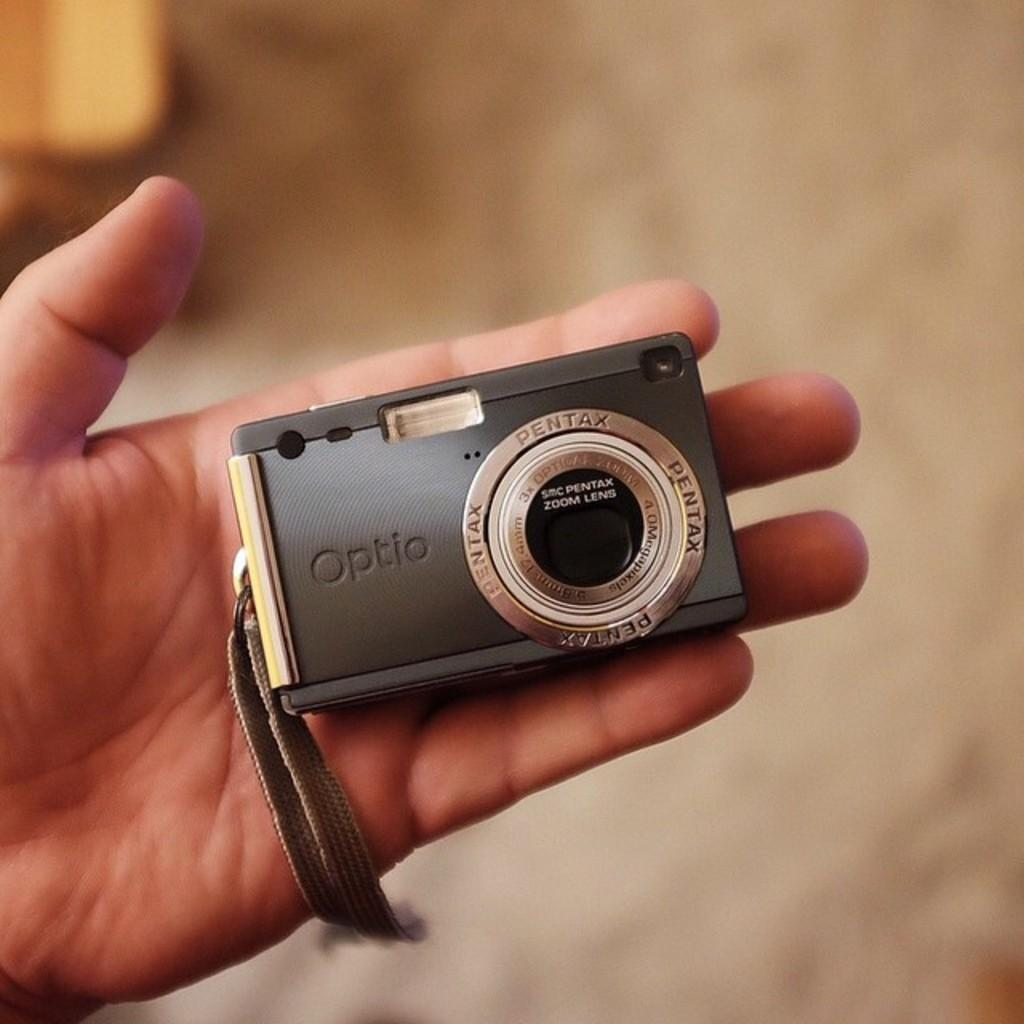What object is being held by a person in the image? There is a camera in the image, and it is being held by a person. What can be inferred about the person's activity based on the presence of the camera? The person is likely taking a photograph or recording a video. What is the condition of the background in the image? The background of the image is blurred. What type of ring can be seen on the person's finger in the image? There is no ring visible on the person's finger in the image. What channel is the person watching on the camera in the image? The image does not depict a television or any channel being watched; it only shows a person holding a camera. 